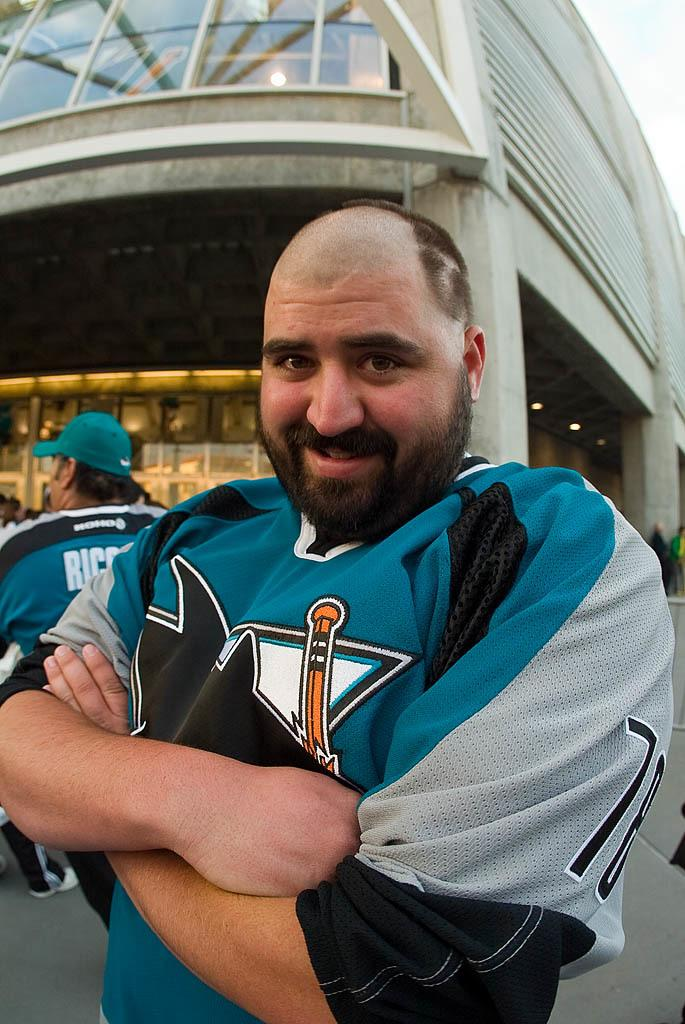<image>
Write a terse but informative summary of the picture. A man stands with his arms crossed wearing a number 78 hockey jersey. 